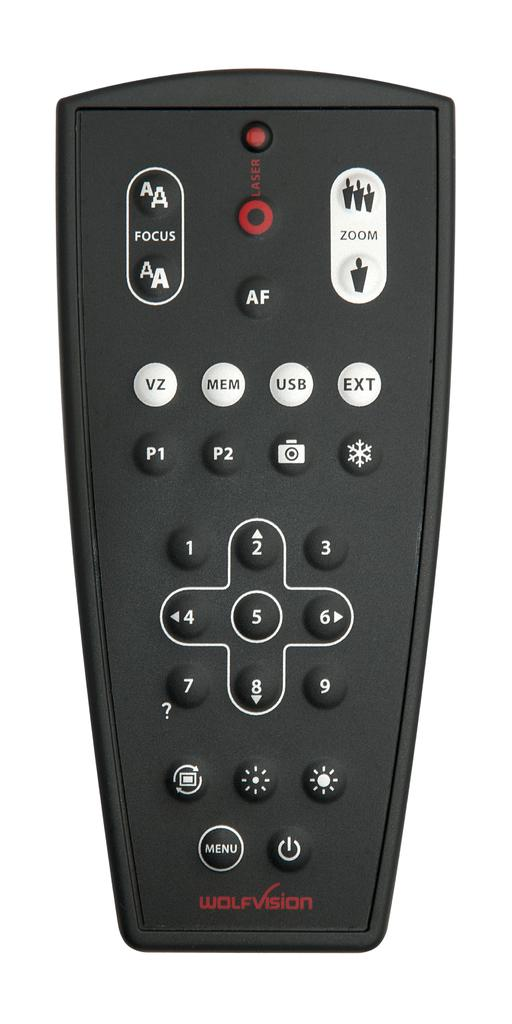<image>
Share a concise interpretation of the image provided. A Wolfvision black remote with a USB button as well. 